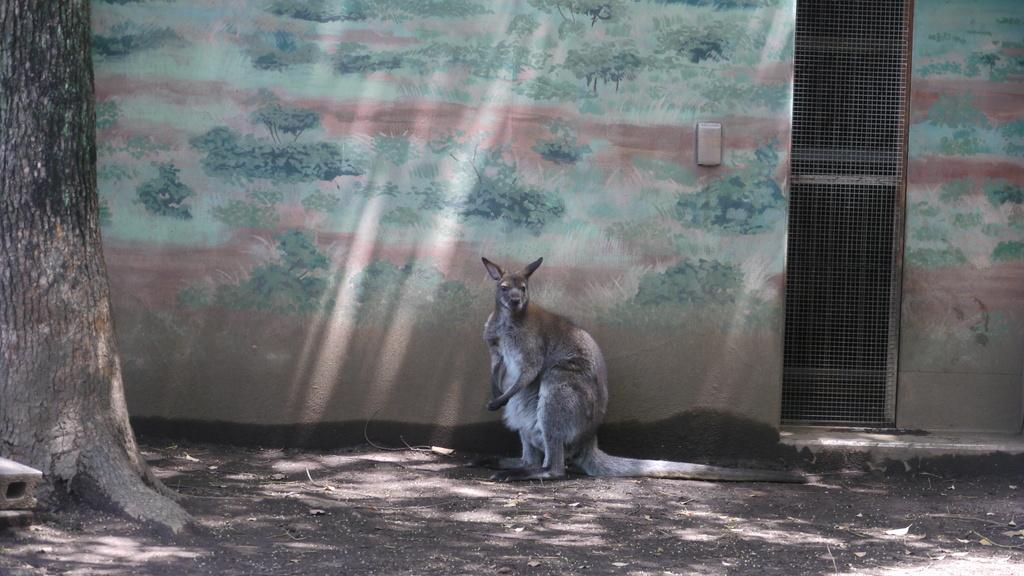What animal is in the picture? There is a kangaroo in the picture. What can be seen on the left side of the image? There is a tree trunk on the left side of the image. What is on the right side of the image? There is a metal grill fence on the right side of the image. What is depicted on the wall in the image? There is a painting of trees on the wall in the image. Where is the mailbox located in the image? There is no mailbox present in the image. What type of bushes can be seen growing near the kangaroo? There are no bushes visible in the image; only a kangaroo, tree trunk, metal grill fence, and a painting of trees on the wall are present. 